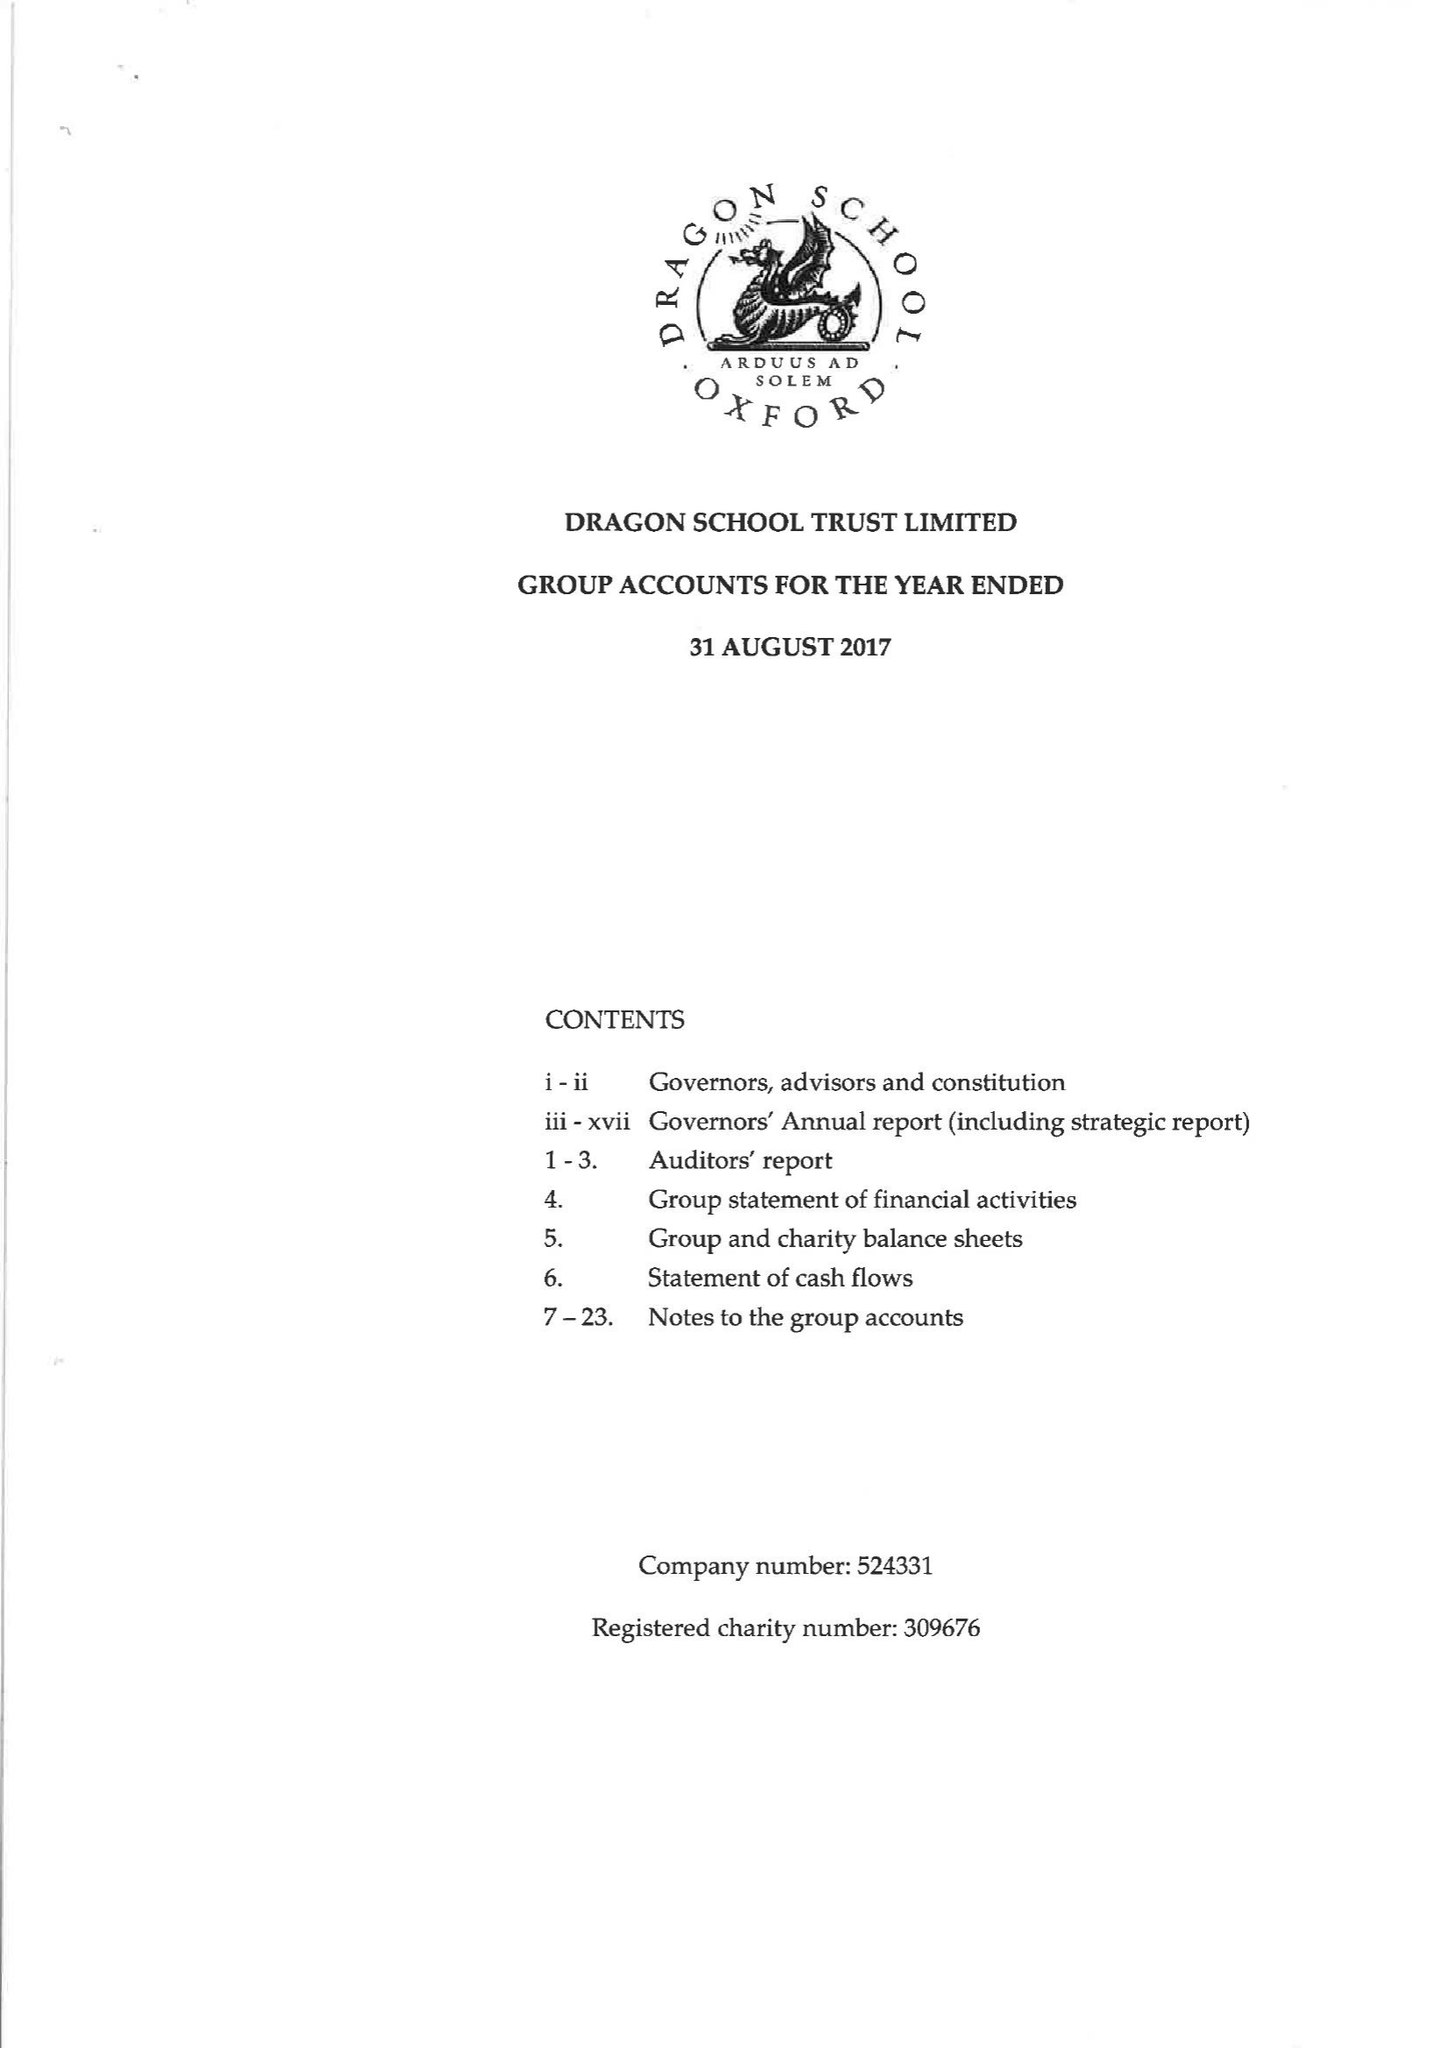What is the value for the address__postcode?
Answer the question using a single word or phrase. OX2 6SS 